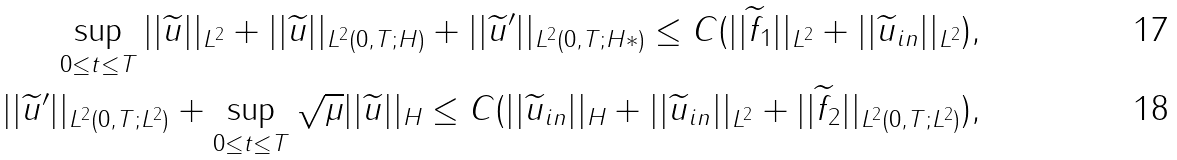Convert formula to latex. <formula><loc_0><loc_0><loc_500><loc_500>\sup _ { 0 \leq t \leq T } | | \widetilde { u } | | _ { L ^ { 2 } } + | | \widetilde { u } | | _ { L ^ { 2 } ( 0 , T ; H ) } + | | \widetilde { u } ^ { \prime } | | _ { L ^ { 2 } ( 0 , T ; H * ) } \leq C ( | | \widetilde { f } _ { 1 } | | _ { L ^ { 2 } } + | | \widetilde { u } _ { i n } | | _ { L ^ { 2 } } ) , \\ | | \widetilde { u } ^ { \prime } | | _ { L ^ { 2 } ( 0 , T ; L ^ { 2 } ) } + \sup _ { 0 \leq t \leq T } \sqrt { \mu } | | \widetilde { u } | | _ { H } \leq C ( | | \widetilde { u } _ { i n } | | _ { H } + | | \widetilde { u } _ { i n } | | _ { L ^ { 2 } } + | | \widetilde { f } _ { 2 } | | _ { L ^ { 2 } ( 0 , T ; L ^ { 2 } ) } ) ,</formula> 